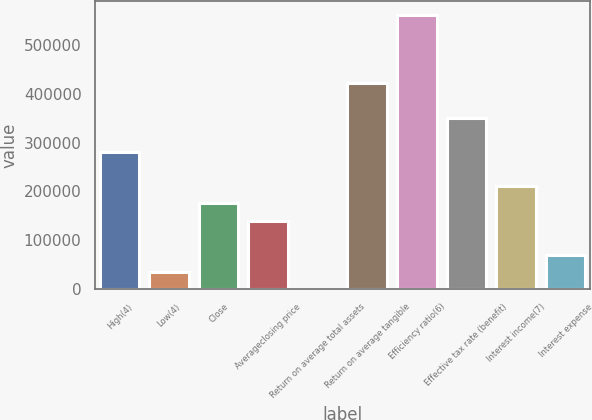<chart> <loc_0><loc_0><loc_500><loc_500><bar_chart><fcel>High(4)<fcel>Low(4)<fcel>Close<fcel>Averageclosing price<fcel>Return on average total assets<fcel>Return on average tangible<fcel>Efficiency ratio(6)<fcel>Effective tax rate (benefit)<fcel>Interest income(7)<fcel>Interest expense<nl><fcel>280892<fcel>35112.4<fcel>175558<fcel>140447<fcel>0.97<fcel>421338<fcel>561783<fcel>351115<fcel>210669<fcel>70223.8<nl></chart> 